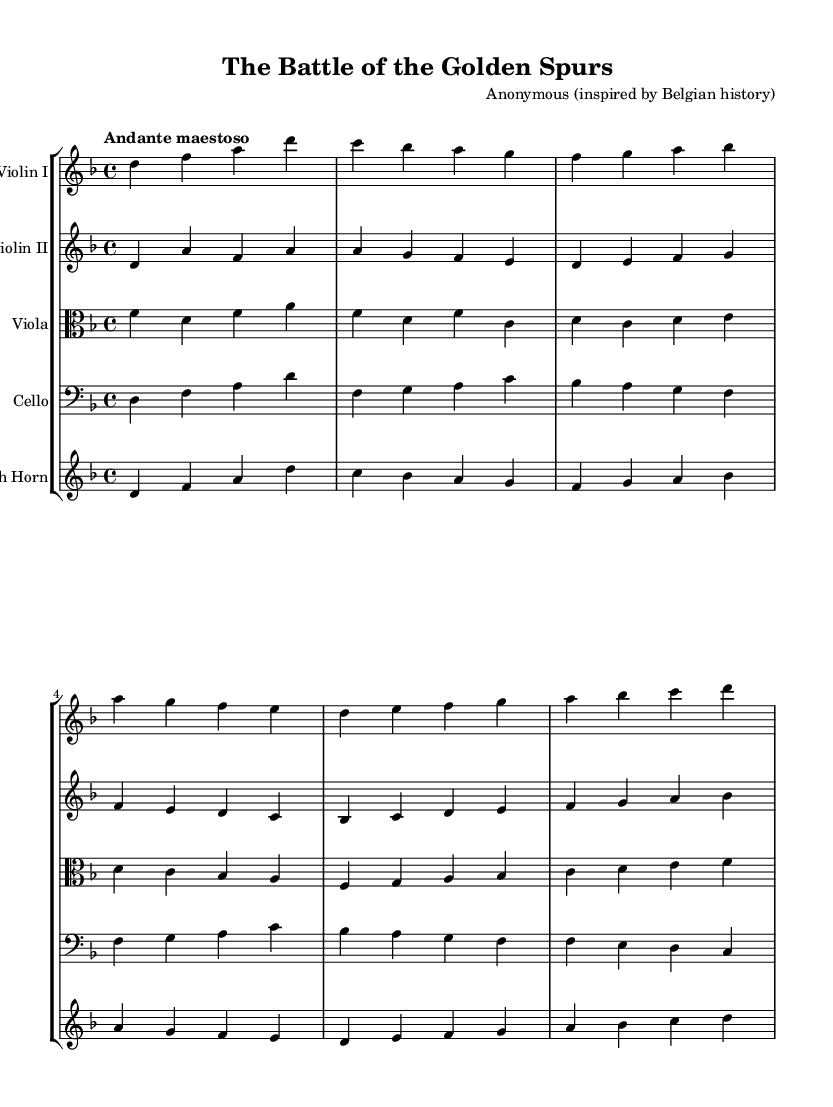What is the key signature of this music? The key signature is D minor, which includes one flat (B flat). This can be determined by looking for the symbols that indicate flats or sharps at the beginning of the staff.
Answer: D minor What is the time signature of this piece? The time signature is 4/4, indicated at the beginning of the score, showing that there are four beats in each measure. Each quarter note gets one beat.
Answer: 4/4 What is the tempo marking of the composition? The tempo marking is "Andante maestoso," which indicates a moderately slow and majestic pace. This is explicitly stated in the text following the time signature.
Answer: Andante maestoso How many instrumental parts are written in the score? The score contains five instrumental parts: Violin I, Violin II, Viola, Cello, and French Horn. This can be counted by looking at the number of staves in the score.
Answer: Five What is the primary theme of the piece, based on its title? The title "The Battle of the Golden Spurs" suggests that the composition is based on a significant historical event— the battle that took place in 1302. The title directly informs us about the contextual theme of the composition.
Answer: Historical event Which instrument plays the lowest pitch in the score? The Cello typically plays the lowest pitch in ensemble music, and examining the staves shows that it has the lowest notes compared to the other instruments. The bass clef also indicates this role.
Answer: Cello 